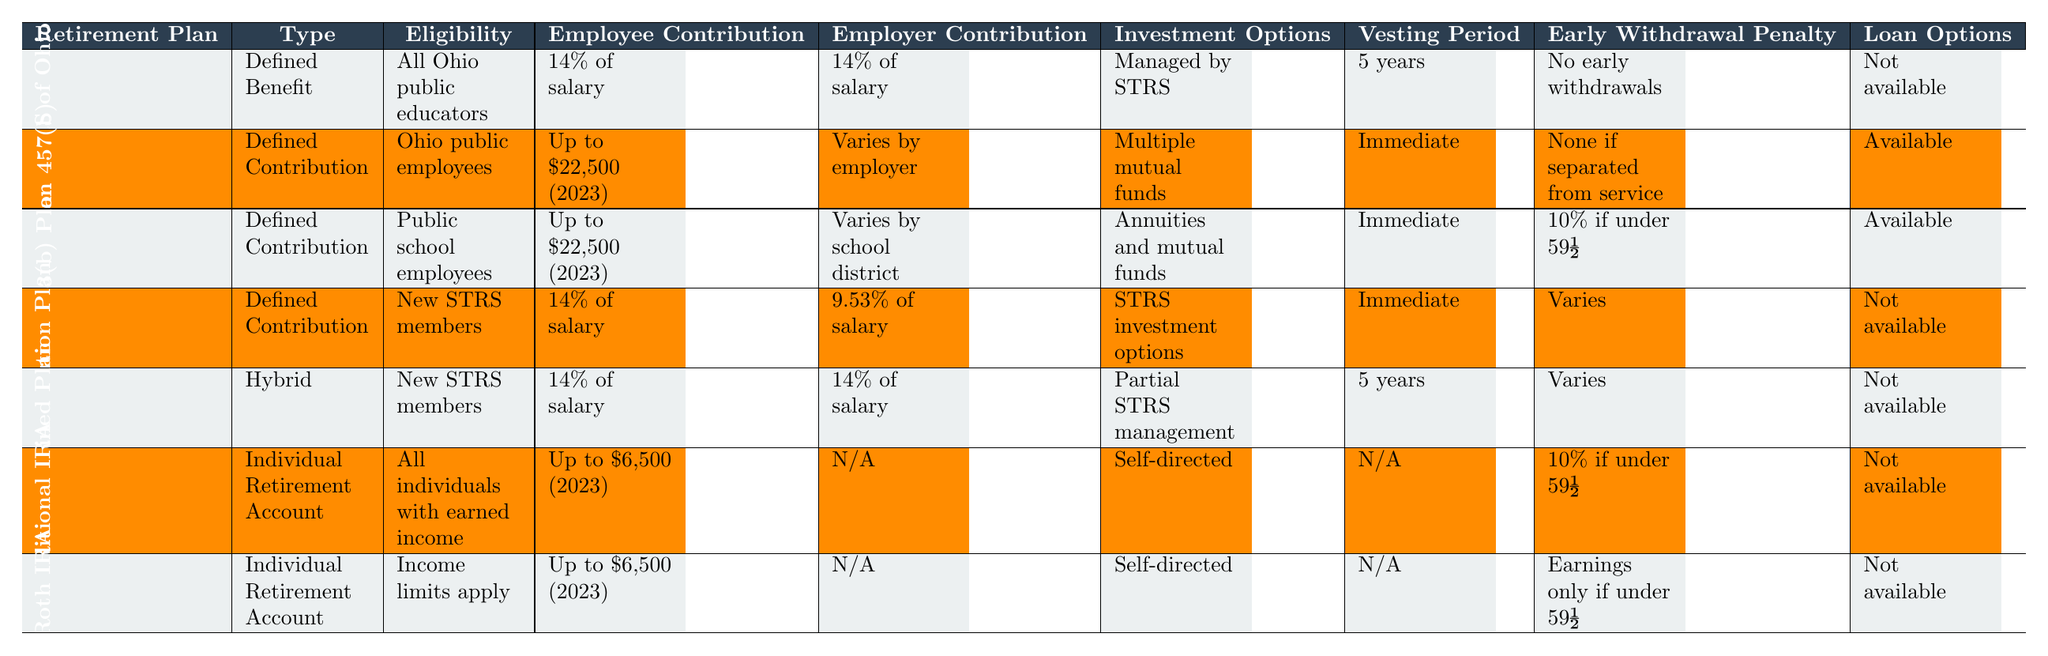What type of retirement plan is the STRS of Ohio? The table lists the "State Teachers Retirement System (STRS) of Ohio" and states that it is a "Defined Benefit" plan.
Answer: Defined Benefit How much do employees contribute to the Ohio Deferred Compensation 457(b) plan? The "Employee Contribution" for the Ohio Deferred Compensation 457(b) plan is stated as "Up to $22,500 (2023)."
Answer: Up to $22,500 Is there an early withdrawal penalty for the 403(b) Plan? According to the table, the early withdrawal penalty for the 403(b) Plan is "10% if under 59½," indicating that there is a penalty associated with early withdrawal.
Answer: Yes Which plan has the highest employer contribution percentage? The STRS of Ohio and the STRS Ohio Combined Plan both have an employer contribution of "14% of salary," which is the highest listed compared to other plans.
Answer: STRS of Ohio and STRS Ohio Combined Plan What is the vesting period for the STRS Ohio Defined Contribution Plan? The table specifies that the vesting period for the STRS Ohio Defined Contribution Plan is "Immediate."
Answer: Immediate If I withdraw early from a Traditional IRA, what is the penalty if I am under 59½? The table indicates that the early withdrawal penalty for a Traditional IRA is "10% if under 59½."
Answer: 10% Which retirement plan has no loan options available? The plans that do not offer loan options according to the table are the STRS of Ohio, STRS Ohio Defined Contribution Plan, STRS Ohio Combined Plan, Traditional IRA, and Roth IRA.
Answer: STRS of Ohio, STRS Ohio Defined Contribution Plan, STRS Ohio Combined Plan, Traditional IRA, Roth IRA How do the employer contributions compare between the STRS Ohio Defined Contribution Plan and the STRS Ohio Combined Plan? The STRS Ohio Defined Contribution Plan has an employer contribution of "9.53% of salary," while the STRS Ohio Combined Plan has "14% of salary." This shows that the STRS Ohio Combined Plan has a higher employer contribution.
Answer: STRS Ohio Combined Plan has a higher contribution What percentage of their salary must new STRS members contribute to their retirement? New STRS members must contribute "14% of salary" to their retirement plan according to the table.
Answer: 14% Is the Ohio Deferred Compensation 457(b) plan available to all educators? The eligibility for the Ohio Deferred Compensation 457(b) plan is "Ohio public employees," meaning it is not available to all educators, only those who are public employees in Ohio.
Answer: No Which retirement plan allows for early withdrawal without a penalty if separated from service? The Ohio Deferred Compensation 457(b) plan allows for "None if separated from service," meaning that early withdrawals can be made without a penalty under this condition.
Answer: Ohio Deferred Compensation 457(b) Plan What are the investment options for the Roth IRA? The table states that the investment options for a Roth IRA are "Self-directed," meaning individuals can choose their investments.
Answer: Self-directed 